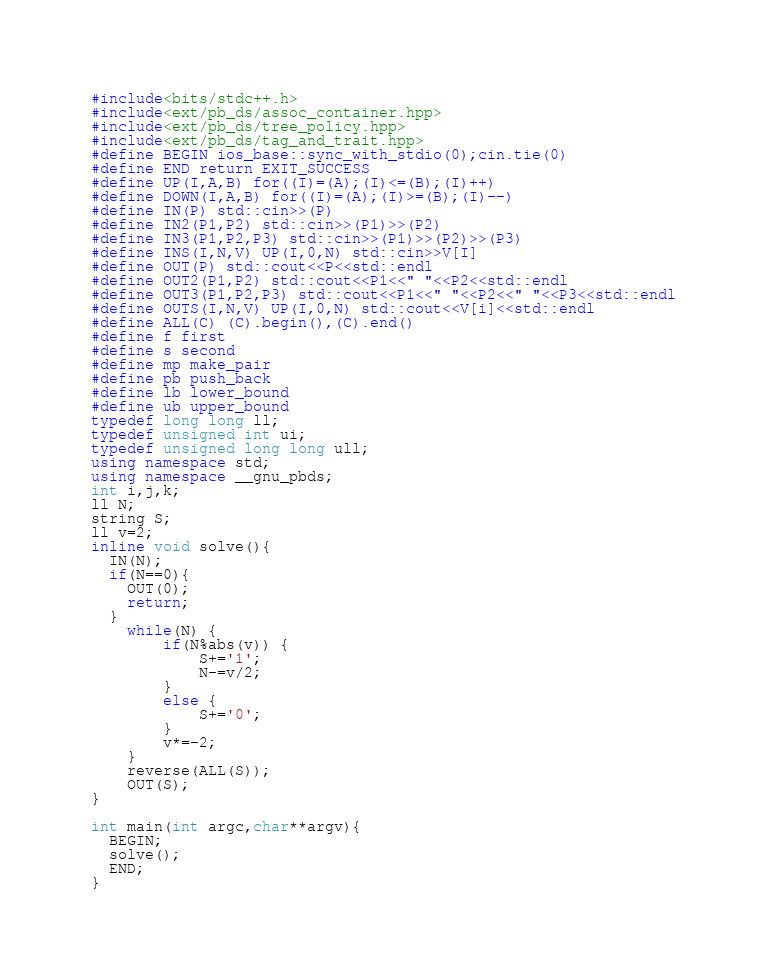<code> <loc_0><loc_0><loc_500><loc_500><_C++_>#include<bits/stdc++.h>
#include<ext/pb_ds/assoc_container.hpp>
#include<ext/pb_ds/tree_policy.hpp>
#include<ext/pb_ds/tag_and_trait.hpp>
#define BEGIN ios_base::sync_with_stdio(0);cin.tie(0)
#define END return EXIT_SUCCESS
#define UP(I,A,B) for((I)=(A);(I)<=(B);(I)++)
#define DOWN(I,A,B) for((I)=(A);(I)>=(B);(I)--)
#define IN(P) std::cin>>(P)
#define IN2(P1,P2) std::cin>>(P1)>>(P2)
#define IN3(P1,P2,P3) std::cin>>(P1)>>(P2)>>(P3)
#define INS(I,N,V) UP(I,0,N) std::cin>>V[I]
#define OUT(P) std::cout<<P<<std::endl
#define OUT2(P1,P2) std::cout<<P1<<" "<<P2<<std::endl
#define OUT3(P1,P2,P3) std::cout<<P1<<" "<<P2<<" "<<P3<<std::endl
#define OUTS(I,N,V) UP(I,0,N) std::cout<<V[i]<<std::endl
#define ALL(C) (C).begin(),(C).end()
#define f first
#define s second
#define mp make_pair
#define pb push_back
#define lb lower_bound
#define ub upper_bound
typedef long long ll;
typedef unsigned int ui;
typedef unsigned long long ull;
using namespace std;
using namespace __gnu_pbds;
int i,j,k;
ll N;
string S;
ll v=2;
inline void solve(){
  IN(N);
  if(N==0){
    OUT(0);
    return;
  }
	while(N) {
		if(N%abs(v)) {
			S+='1';
			N-=v/2;
		}
		else {
			S+='0';
		}
		v*=-2;
	}
	reverse(ALL(S));
	OUT(S);
}

int main(int argc,char**argv){
  BEGIN;
  solve();
  END;
}
</code> 